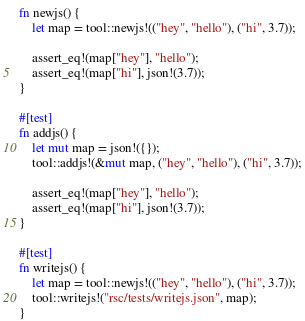<code> <loc_0><loc_0><loc_500><loc_500><_Rust_>fn newjs() {
    let map = tool::newjs!(("hey", "hello"), ("hi", 3.7));

    assert_eq!(map["hey"], "hello");
    assert_eq!(map["hi"], json!(3.7));
}

#[test]
fn addjs() {
    let mut map = json!({});
    tool::addjs!(&mut map, ("hey", "hello"), ("hi", 3.7));

    assert_eq!(map["hey"], "hello");
    assert_eq!(map["hi"], json!(3.7));
}

#[test]
fn writejs() {
    let map = tool::newjs!(("hey", "hello"), ("hi", 3.7));
    tool::writejs!("rsc/tests/writejs.json", map);
}
</code> 